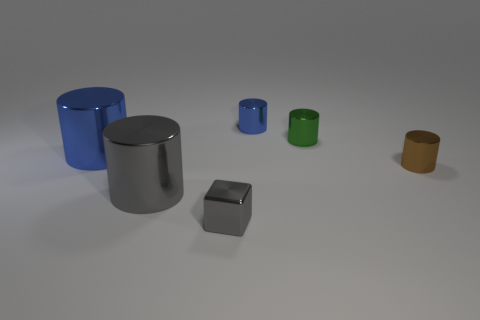Subtract 1 cylinders. How many cylinders are left? 4 Subtract all purple cylinders. Subtract all blue balls. How many cylinders are left? 5 Add 2 gray cylinders. How many objects exist? 8 Subtract all cylinders. How many objects are left? 1 Add 5 large gray metallic cylinders. How many large gray metallic cylinders are left? 6 Add 6 green cylinders. How many green cylinders exist? 7 Subtract 0 purple balls. How many objects are left? 6 Subtract all cyan blocks. Subtract all gray shiny objects. How many objects are left? 4 